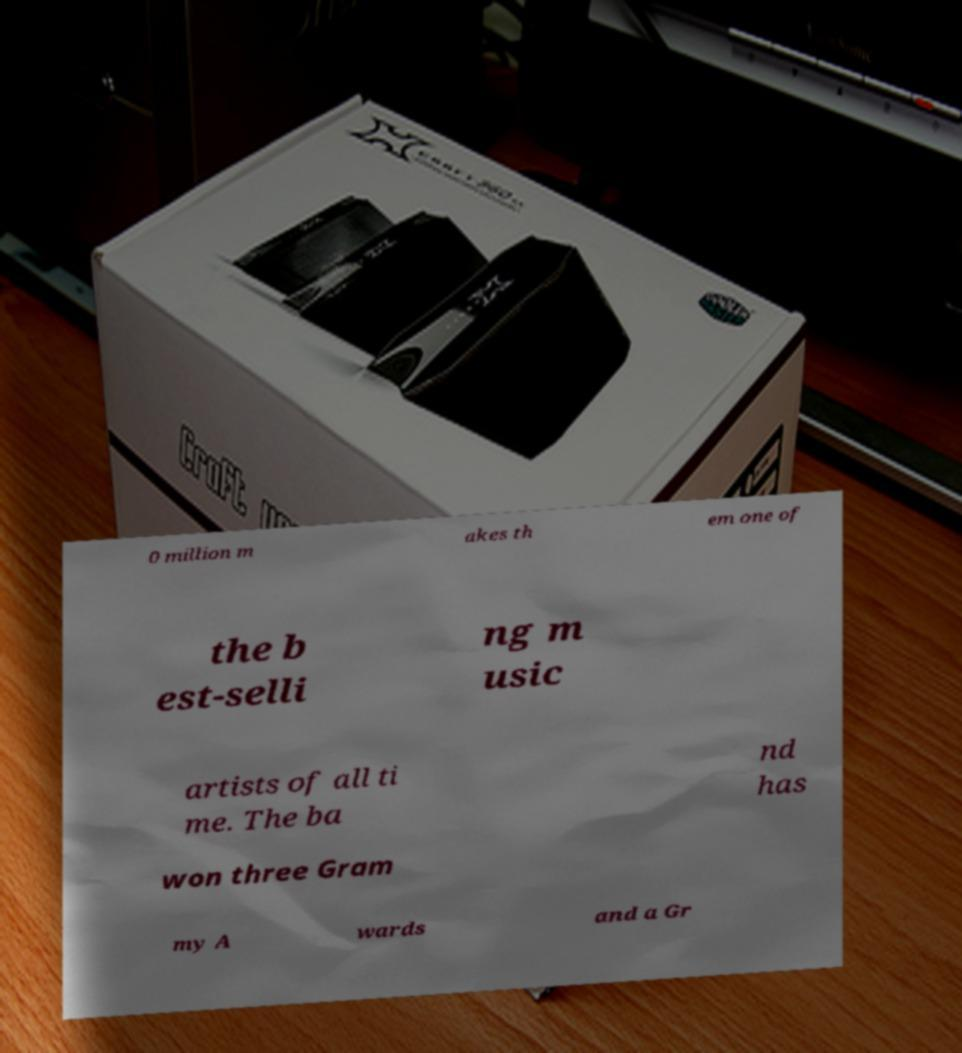What messages or text are displayed in this image? I need them in a readable, typed format. 0 million m akes th em one of the b est-selli ng m usic artists of all ti me. The ba nd has won three Gram my A wards and a Gr 